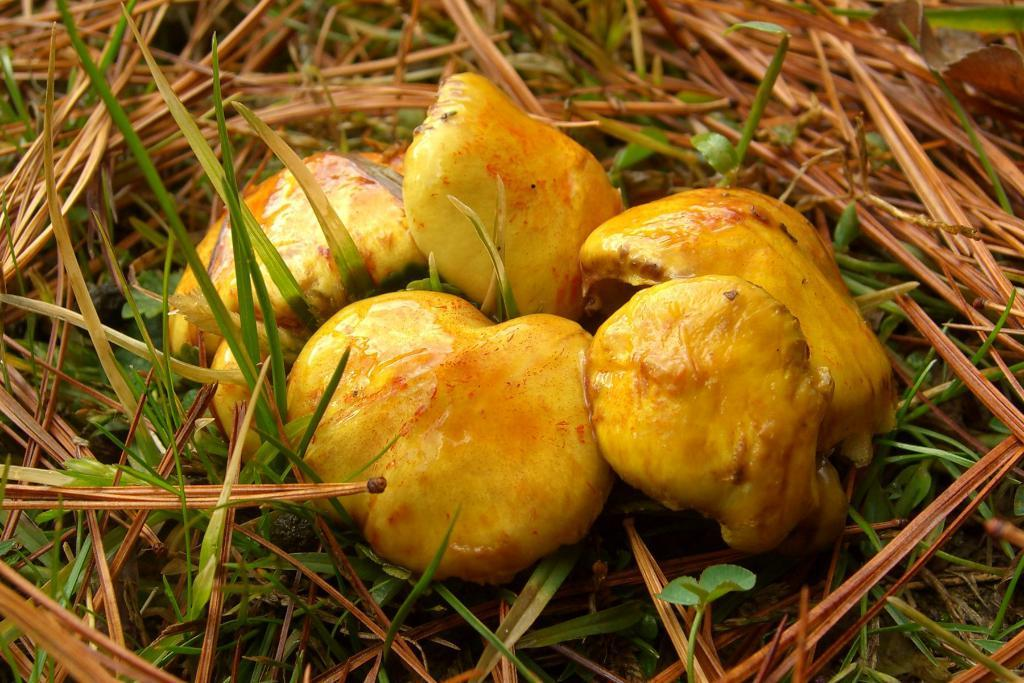What type of objects are on the ground in the image? There are fruits and lawn straw on the ground in the image. Can you describe the fruits in the image? The facts provided do not specify the type of fruits in the image. What is the purpose of the lawn straw in the image? The purpose of the lawn straw in the image is not mentioned in the facts. What type of zephyr can be seen in the image? There is no mention of a zephyr in the image. 